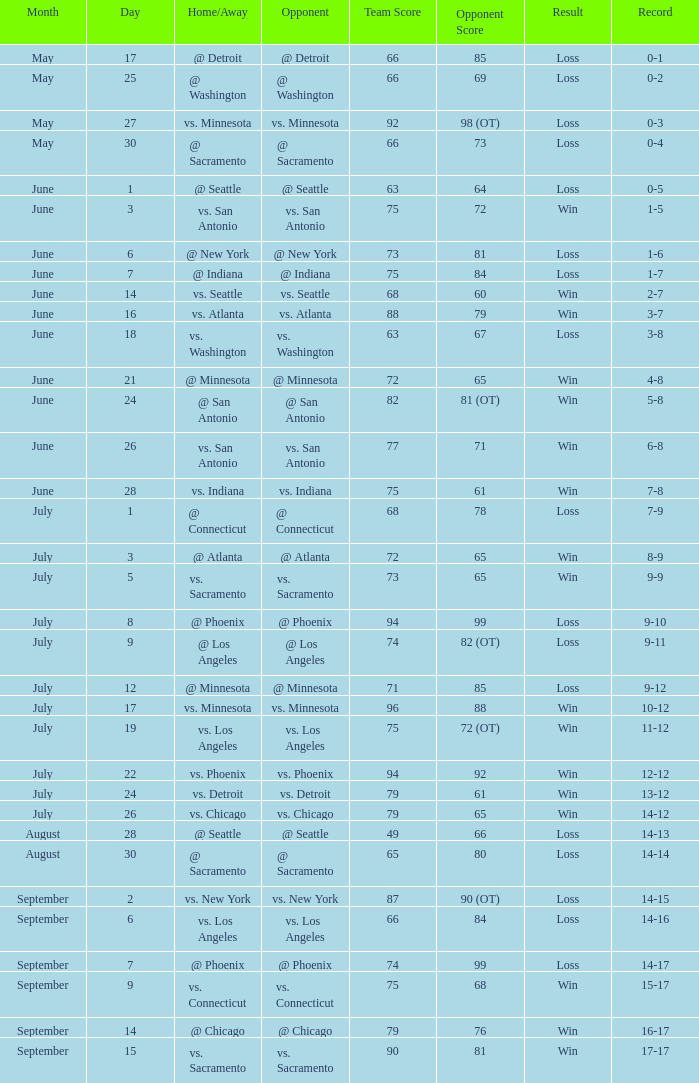What is the Record of the game on June 24? 5-8. 